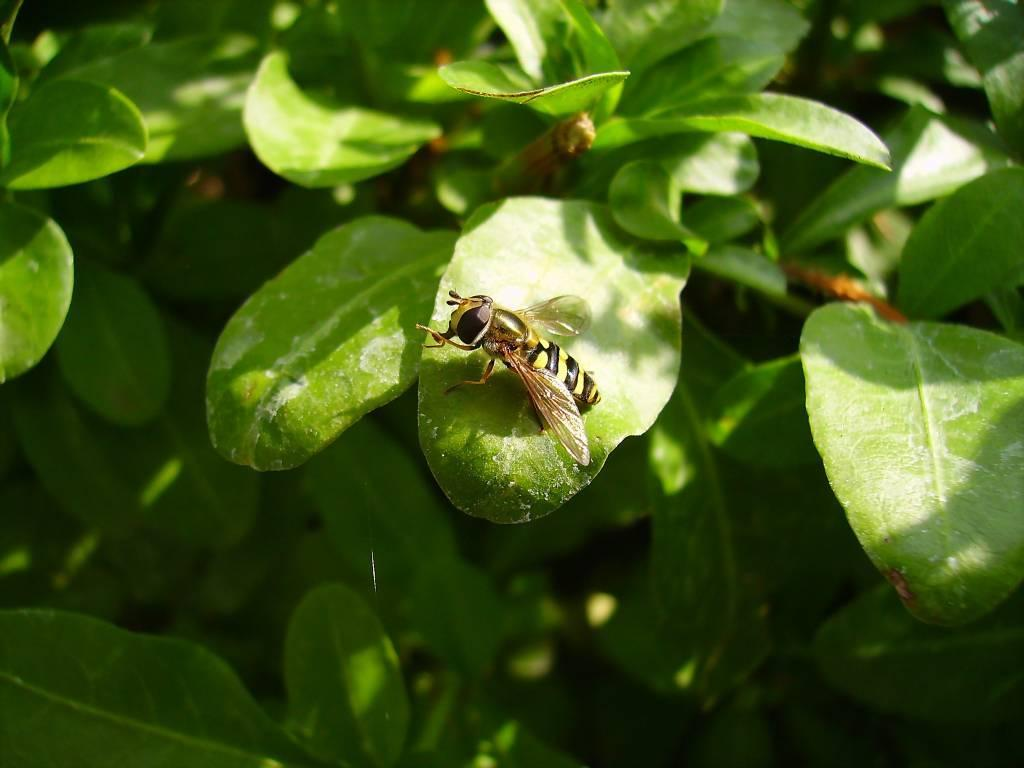What type of plant is represented in the image? The image contains leaves of a plant. Can you describe any specific details about the plant? There is a honey bee on a leaf in the image. What is the name of the star that the plant orbits in the image? There is no star present in the image, and therefore no such orbit can be observed. Can you tell me how many pears are visible on the plant in the image? There are no pears present on the plant in the image. 